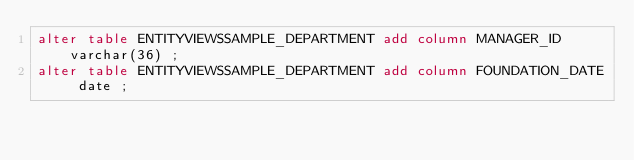<code> <loc_0><loc_0><loc_500><loc_500><_SQL_>alter table ENTITYVIEWSSAMPLE_DEPARTMENT add column MANAGER_ID varchar(36) ;
alter table ENTITYVIEWSSAMPLE_DEPARTMENT add column FOUNDATION_DATE date ;
</code> 